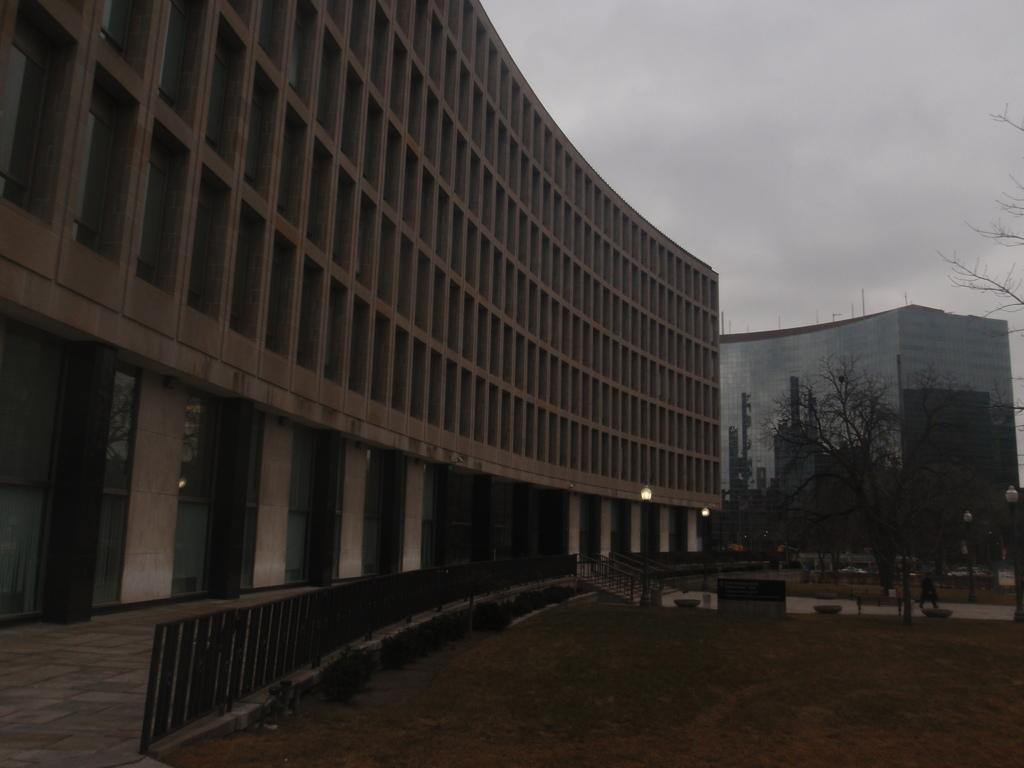Can you describe this image briefly? In this image I can see few trees. In the background I can see few buildings in cream color and I can also see the glass building and the sky is in white color. 